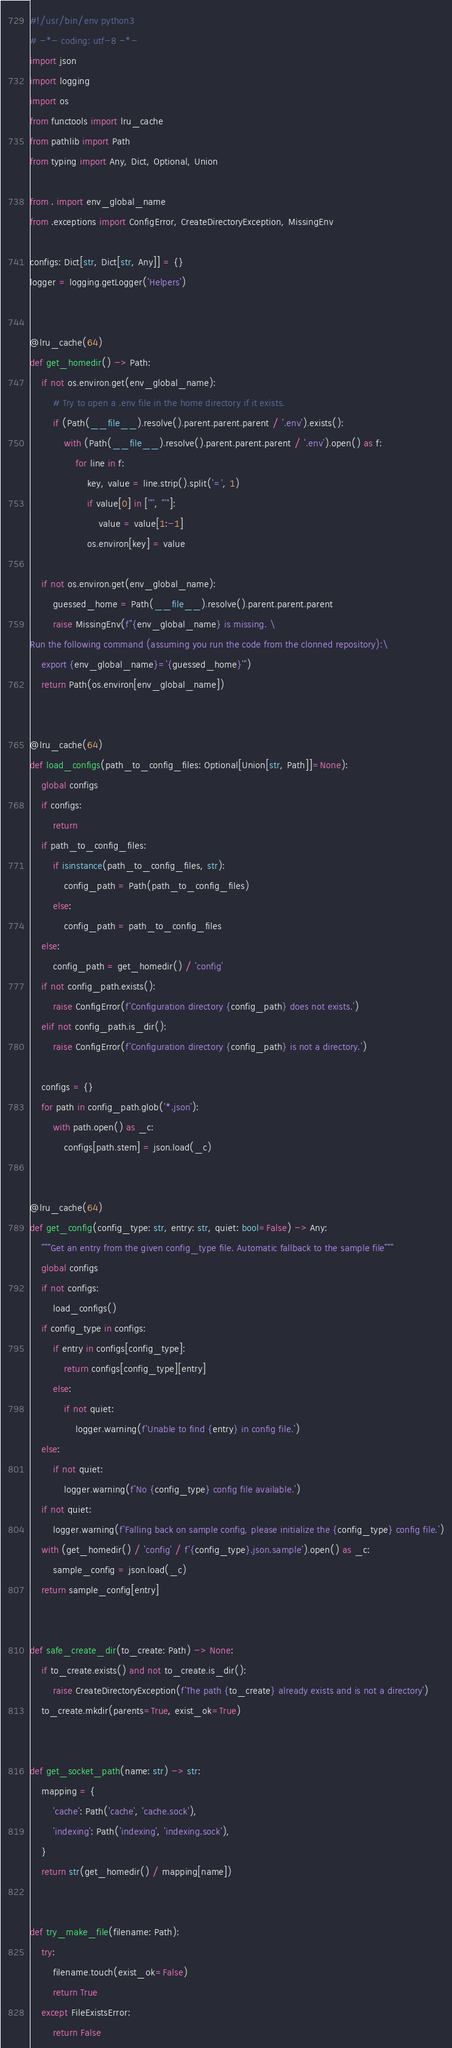Convert code to text. <code><loc_0><loc_0><loc_500><loc_500><_Python_>#!/usr/bin/env python3
# -*- coding: utf-8 -*-
import json
import logging
import os
from functools import lru_cache
from pathlib import Path
from typing import Any, Dict, Optional, Union

from . import env_global_name
from .exceptions import ConfigError, CreateDirectoryException, MissingEnv

configs: Dict[str, Dict[str, Any]] = {}
logger = logging.getLogger('Helpers')


@lru_cache(64)
def get_homedir() -> Path:
    if not os.environ.get(env_global_name):
        # Try to open a .env file in the home directory if it exists.
        if (Path(__file__).resolve().parent.parent.parent / '.env').exists():
            with (Path(__file__).resolve().parent.parent.parent / '.env').open() as f:
                for line in f:
                    key, value = line.strip().split('=', 1)
                    if value[0] in ['"', "'"]:
                        value = value[1:-1]
                    os.environ[key] = value

    if not os.environ.get(env_global_name):
        guessed_home = Path(__file__).resolve().parent.parent.parent
        raise MissingEnv(f"{env_global_name} is missing. \
Run the following command (assuming you run the code from the clonned repository):\
    export {env_global_name}='{guessed_home}'")
    return Path(os.environ[env_global_name])


@lru_cache(64)
def load_configs(path_to_config_files: Optional[Union[str, Path]]=None):
    global configs
    if configs:
        return
    if path_to_config_files:
        if isinstance(path_to_config_files, str):
            config_path = Path(path_to_config_files)
        else:
            config_path = path_to_config_files
    else:
        config_path = get_homedir() / 'config'
    if not config_path.exists():
        raise ConfigError(f'Configuration directory {config_path} does not exists.')
    elif not config_path.is_dir():
        raise ConfigError(f'Configuration directory {config_path} is not a directory.')

    configs = {}
    for path in config_path.glob('*.json'):
        with path.open() as _c:
            configs[path.stem] = json.load(_c)


@lru_cache(64)
def get_config(config_type: str, entry: str, quiet: bool=False) -> Any:
    """Get an entry from the given config_type file. Automatic fallback to the sample file"""
    global configs
    if not configs:
        load_configs()
    if config_type in configs:
        if entry in configs[config_type]:
            return configs[config_type][entry]
        else:
            if not quiet:
                logger.warning(f'Unable to find {entry} in config file.')
    else:
        if not quiet:
            logger.warning(f'No {config_type} config file available.')
    if not quiet:
        logger.warning(f'Falling back on sample config, please initialize the {config_type} config file.')
    with (get_homedir() / 'config' / f'{config_type}.json.sample').open() as _c:
        sample_config = json.load(_c)
    return sample_config[entry]


def safe_create_dir(to_create: Path) -> None:
    if to_create.exists() and not to_create.is_dir():
        raise CreateDirectoryException(f'The path {to_create} already exists and is not a directory')
    to_create.mkdir(parents=True, exist_ok=True)


def get_socket_path(name: str) -> str:
    mapping = {
        'cache': Path('cache', 'cache.sock'),
        'indexing': Path('indexing', 'indexing.sock'),
    }
    return str(get_homedir() / mapping[name])


def try_make_file(filename: Path):
    try:
        filename.touch(exist_ok=False)
        return True
    except FileExistsError:
        return False
</code> 